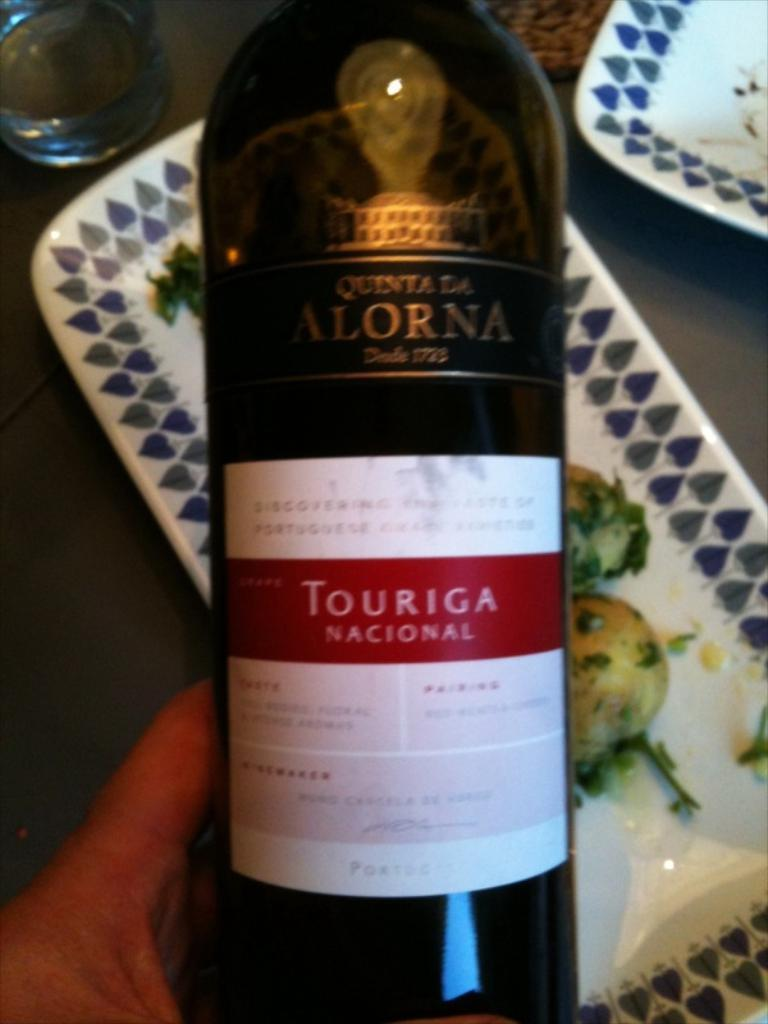<image>
Offer a succinct explanation of the picture presented. A person is holding a wine bottle that says Quenta Da Alorna. 